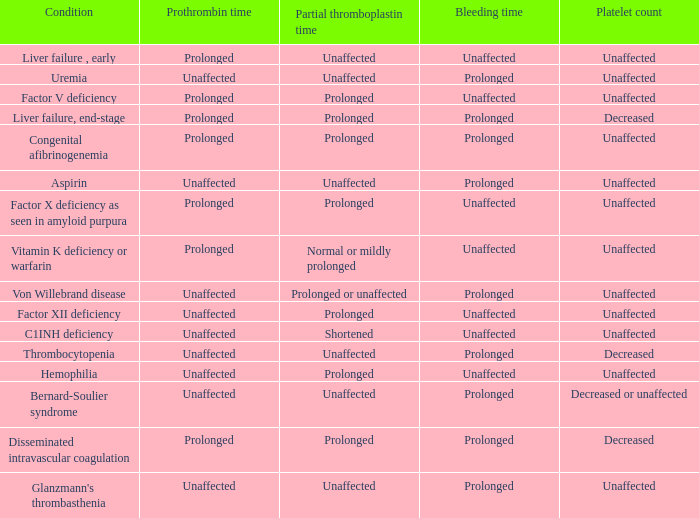Which Condition has an unaffected Prothrombin time and a Bleeding time, and a Partial thromboplastin time of prolonged? Hemophilia, Factor XII deficiency. 